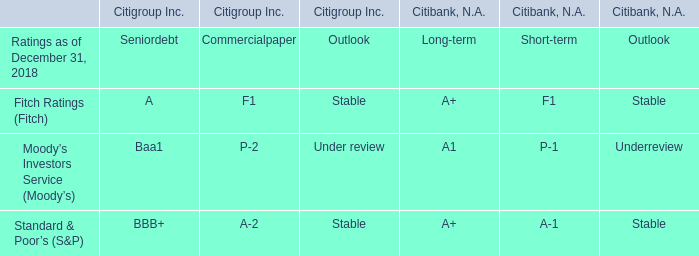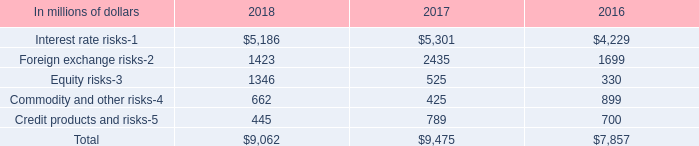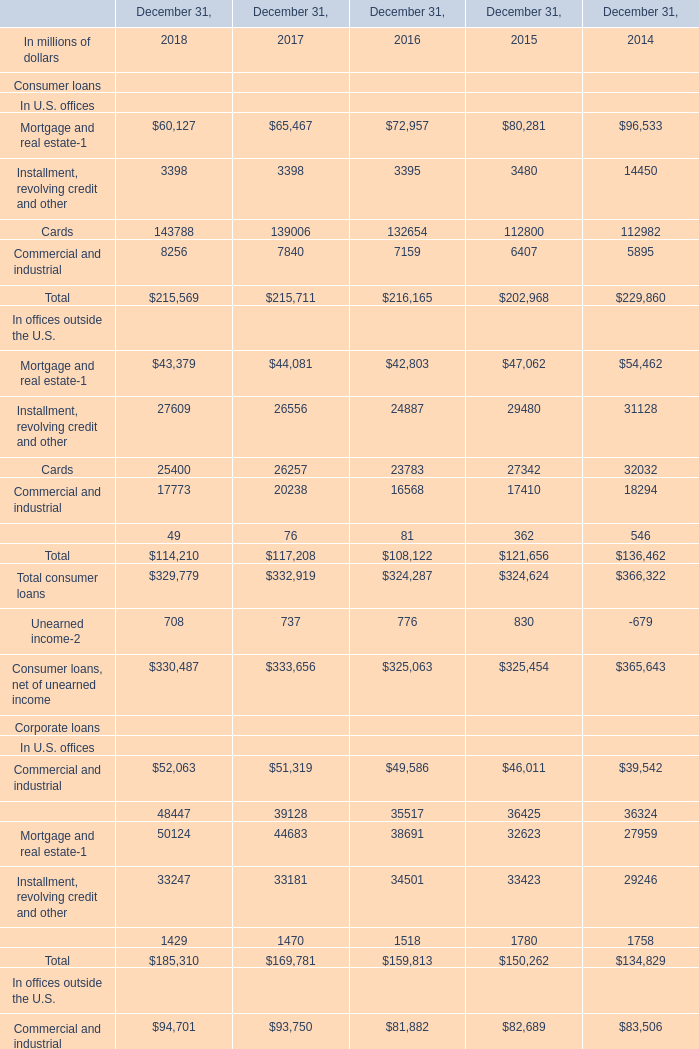What will Mortgage and real estate In U.S. offices reach in 2019 if it continues to grow at its current rate? (in millions) 
Computations: ((1 + ((60127 - 65467) / 65467)) * 60127)
Answer: 55222.57212. 